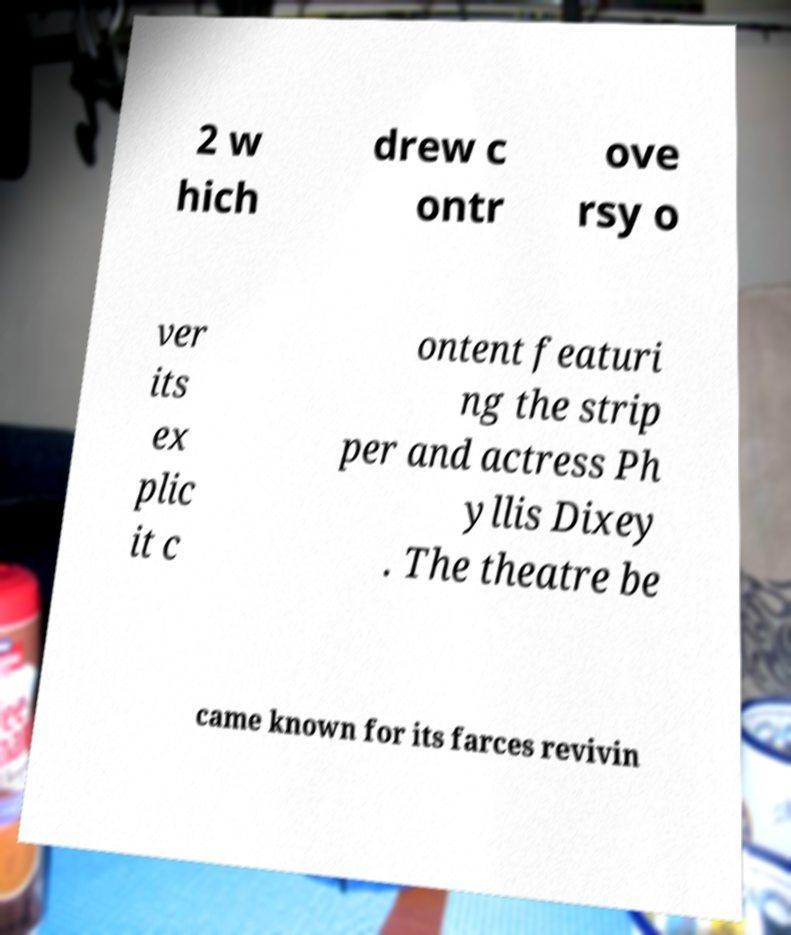What messages or text are displayed in this image? I need them in a readable, typed format. 2 w hich drew c ontr ove rsy o ver its ex plic it c ontent featuri ng the strip per and actress Ph yllis Dixey . The theatre be came known for its farces revivin 